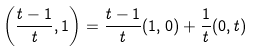<formula> <loc_0><loc_0><loc_500><loc_500>\left ( \frac { t - 1 } t , 1 \right ) = \frac { t - 1 } t ( 1 , 0 ) + \frac { 1 } { t } ( 0 , t )</formula> 